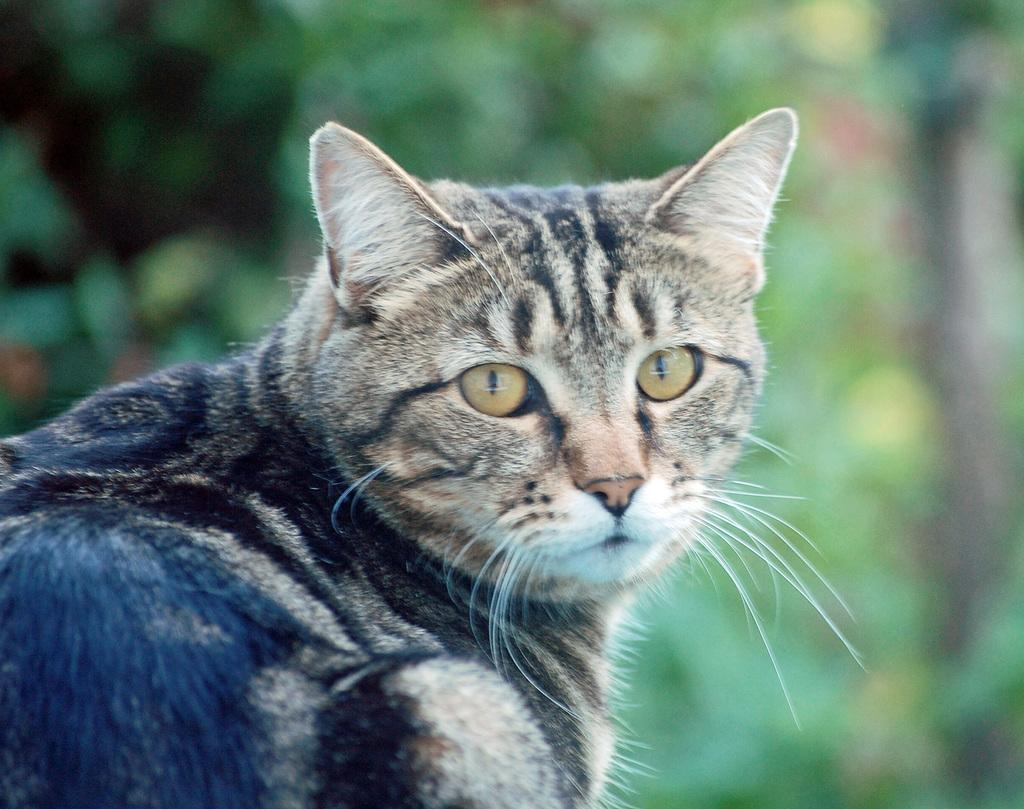What is there is a cat in the center of the image, what color is it? The cat is black and brown in color. What can be seen in the background of the image? There are trees in the background of the image. Is there a crate in the image that the cat is sitting on? There is no crate present in the image; the cat is in the center of the image without any visible crate. 